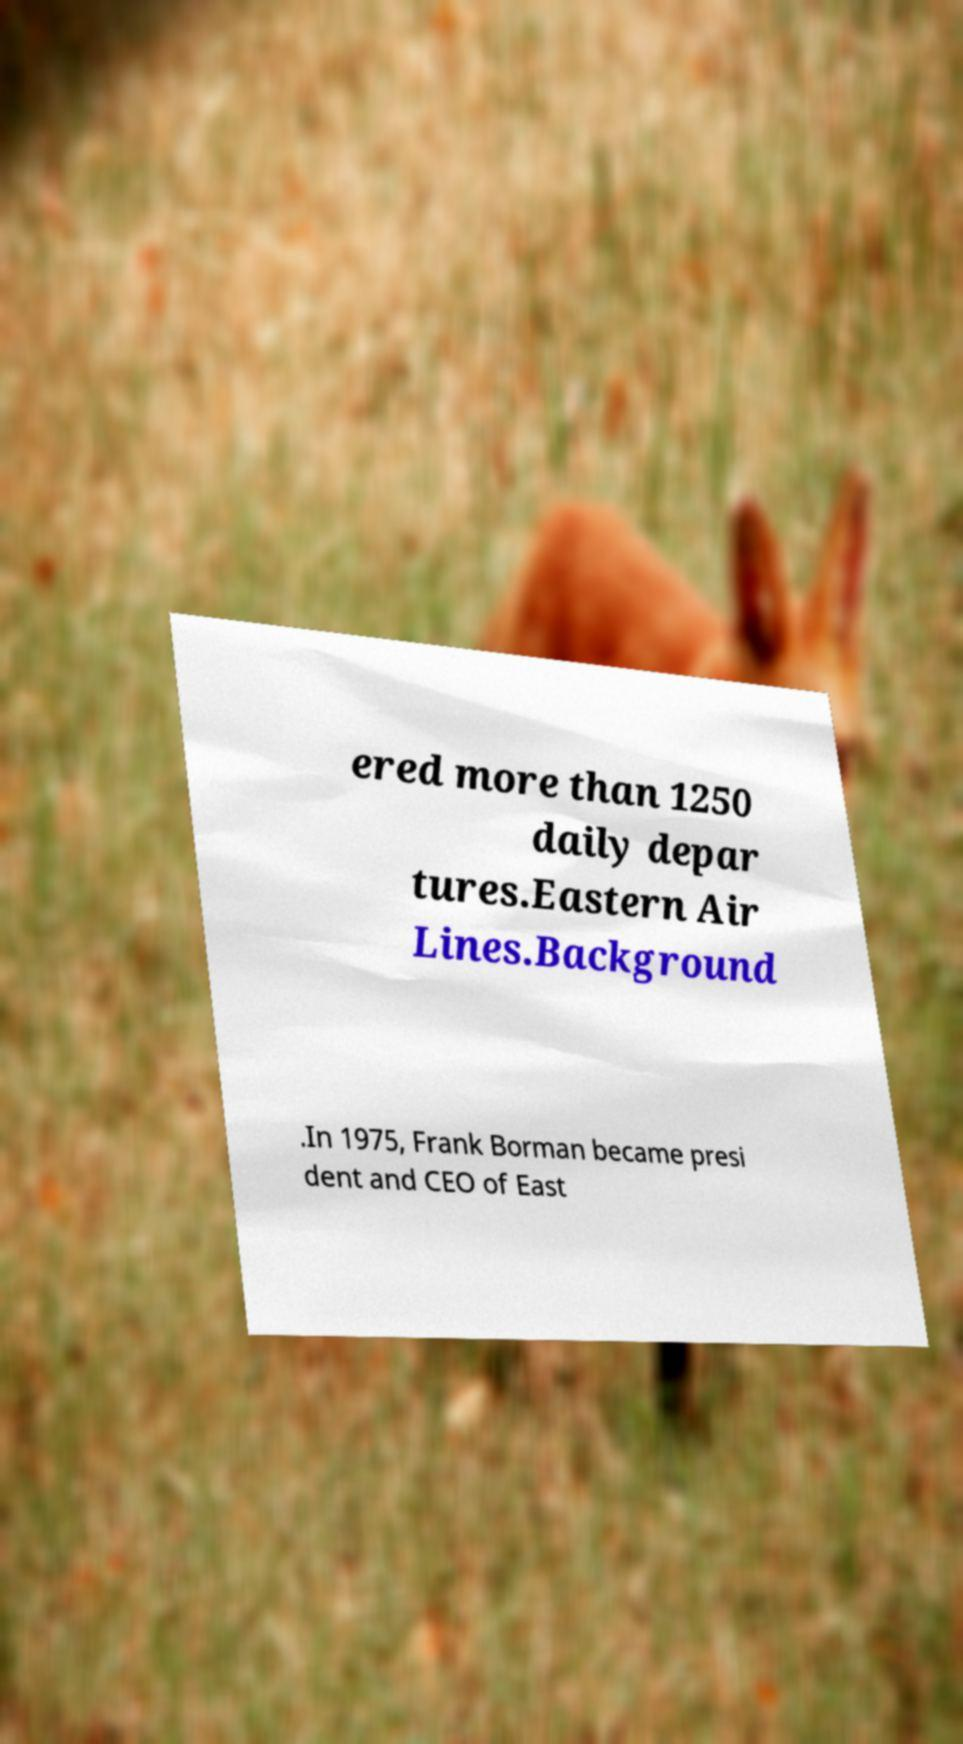Can you read and provide the text displayed in the image?This photo seems to have some interesting text. Can you extract and type it out for me? ered more than 1250 daily depar tures.Eastern Air Lines.Background .In 1975, Frank Borman became presi dent and CEO of East 